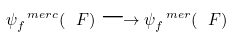Convert formula to latex. <formula><loc_0><loc_0><loc_500><loc_500>\psi _ { f } ^ { \ m e r c } ( \ F ) \longrightarrow \psi _ { f } ^ { \ m e r } ( \ F )</formula> 